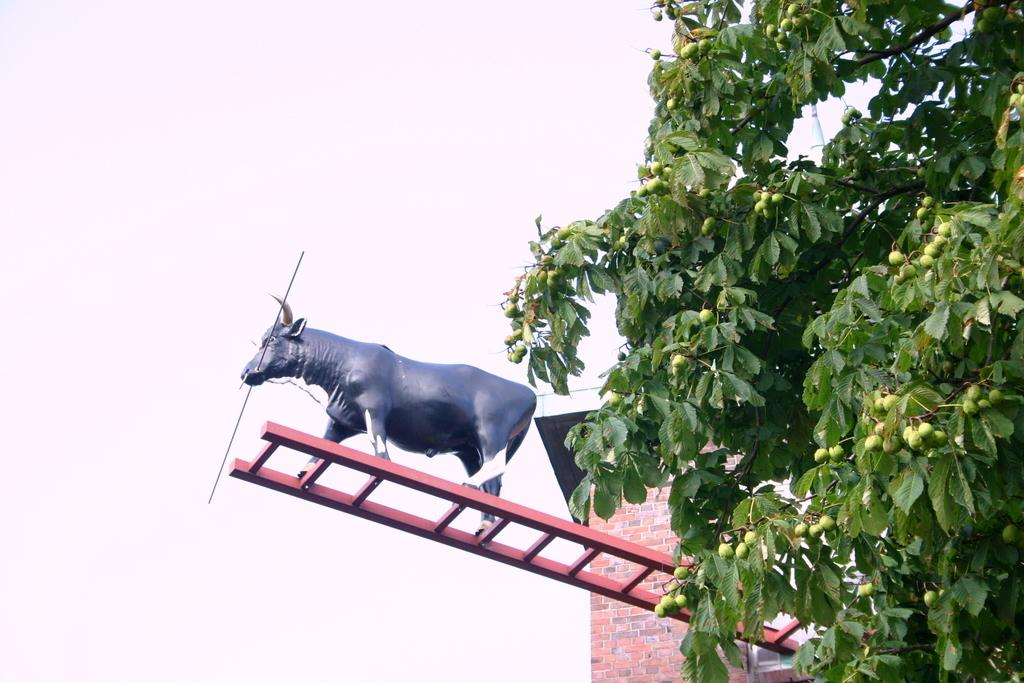What is the main subject of the image? There is a statue of an animal in the image. Where is the statue located? The statue is on a ladder. What can be seen in the background of the image? The sky is visible in the background of the image. What type of curtain is hanging from the statue? There is no curtain present in the image; the statue is on a ladder, and the sky is visible in the background. 